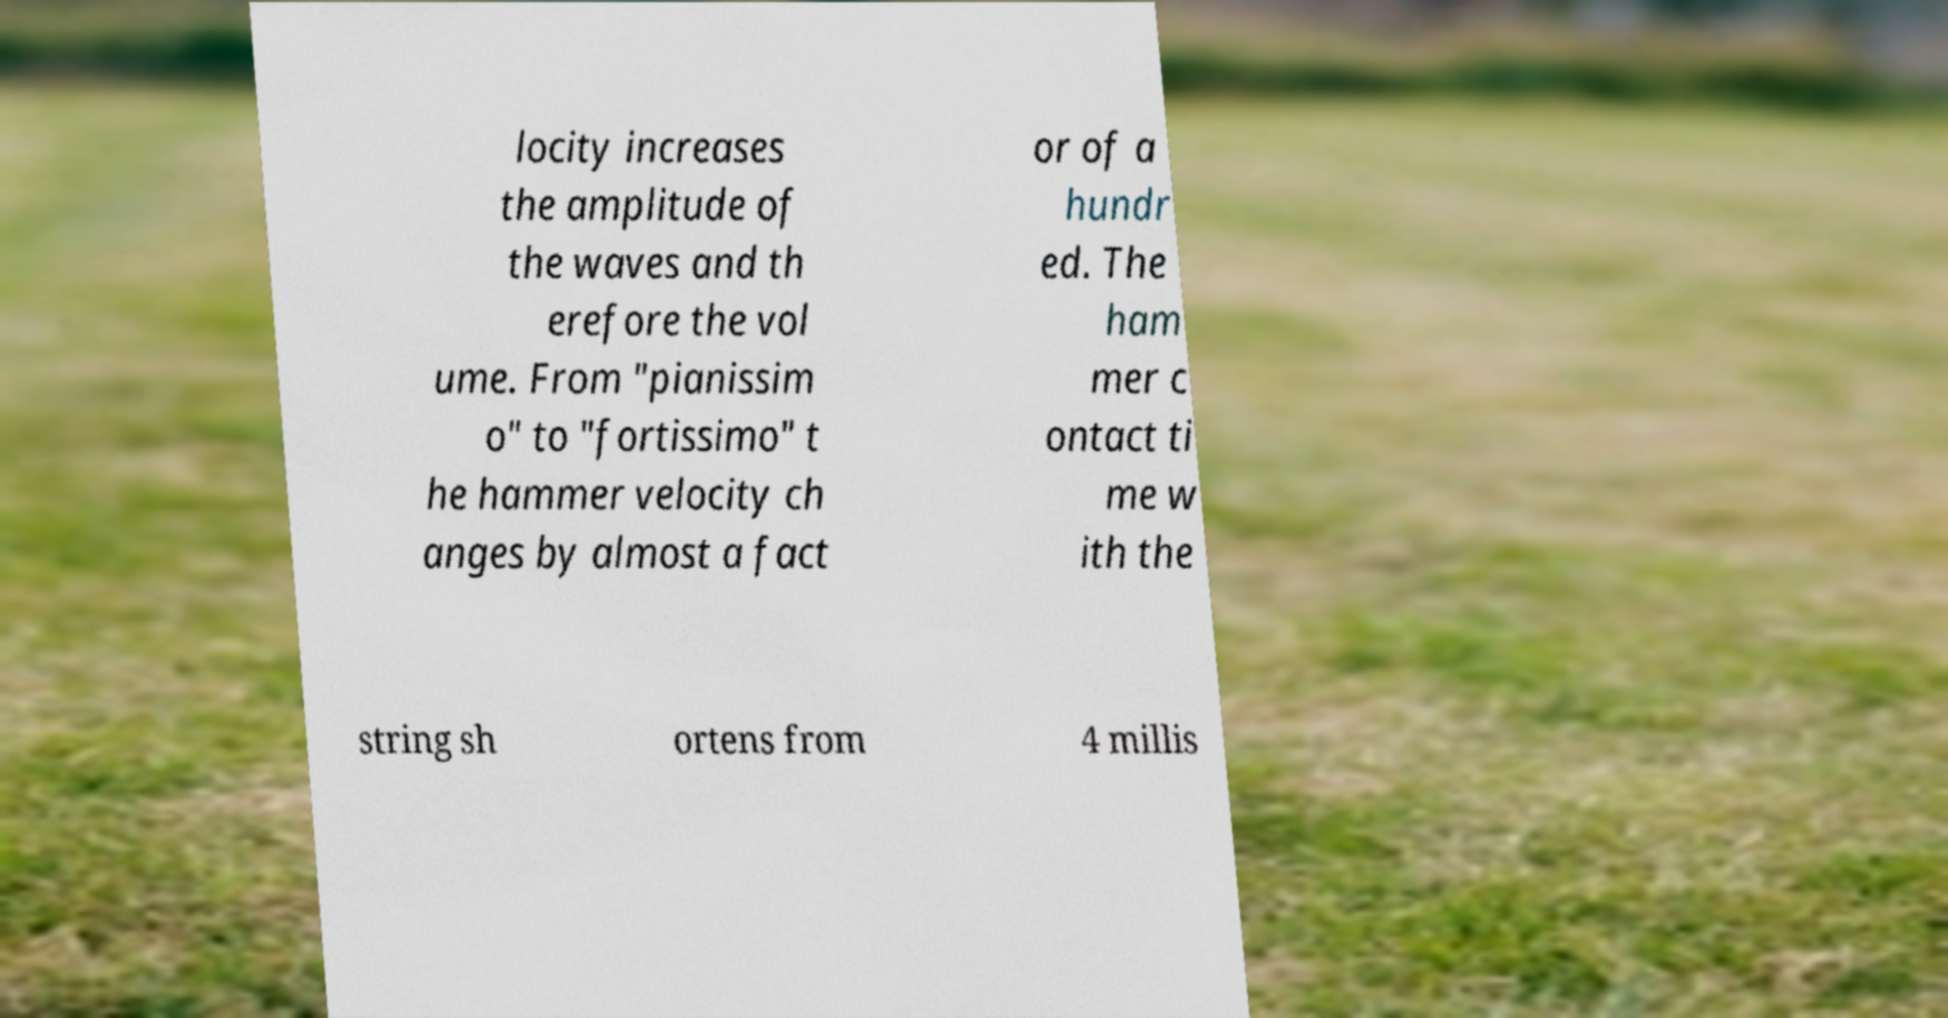I need the written content from this picture converted into text. Can you do that? locity increases the amplitude of the waves and th erefore the vol ume. From "pianissim o" to "fortissimo" t he hammer velocity ch anges by almost a fact or of a hundr ed. The ham mer c ontact ti me w ith the string sh ortens from 4 millis 